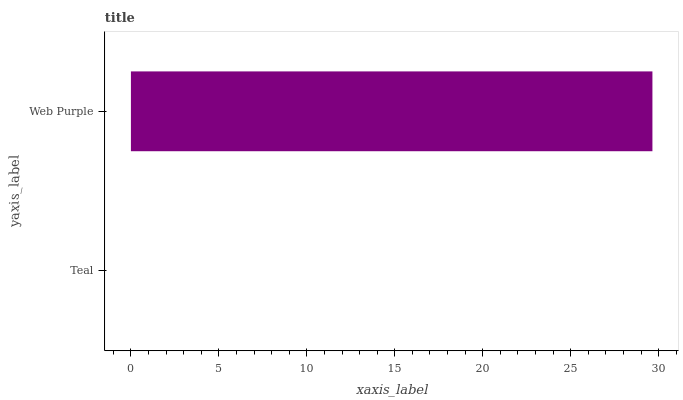Is Teal the minimum?
Answer yes or no. Yes. Is Web Purple the maximum?
Answer yes or no. Yes. Is Web Purple the minimum?
Answer yes or no. No. Is Web Purple greater than Teal?
Answer yes or no. Yes. Is Teal less than Web Purple?
Answer yes or no. Yes. Is Teal greater than Web Purple?
Answer yes or no. No. Is Web Purple less than Teal?
Answer yes or no. No. Is Web Purple the high median?
Answer yes or no. Yes. Is Teal the low median?
Answer yes or no. Yes. Is Teal the high median?
Answer yes or no. No. Is Web Purple the low median?
Answer yes or no. No. 